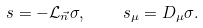Convert formula to latex. <formula><loc_0><loc_0><loc_500><loc_500>s = - \mathcal { L } _ { \vec { n } } \sigma , \quad s _ { \mu } = D _ { \mu } \sigma .</formula> 